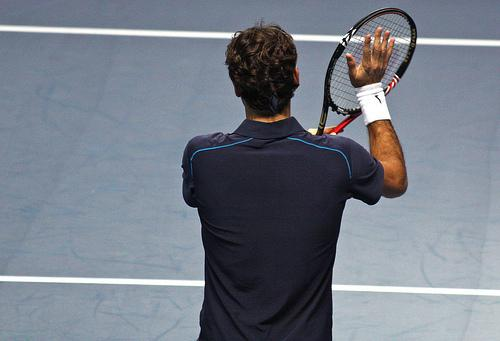Question: what sport is he playing?
Choices:
A. Tennis.
B. Football.
C. Golf.
D. Soccer.
Answer with the letter. Answer: A Question: how many hands can you see?
Choices:
A. Two.
B. One.
C. Three.
D. Four.
Answer with the letter. Answer: B Question: how many fingers do you see?
Choices:
A. 8.
B. 9.
C. 5.
D. 3.
Answer with the letter. Answer: C Question: what is the man holding?
Choices:
A. Baseball bat.
B. Tennis Racket.
C. Football helmet.
D. Golf club.
Answer with the letter. Answer: B 